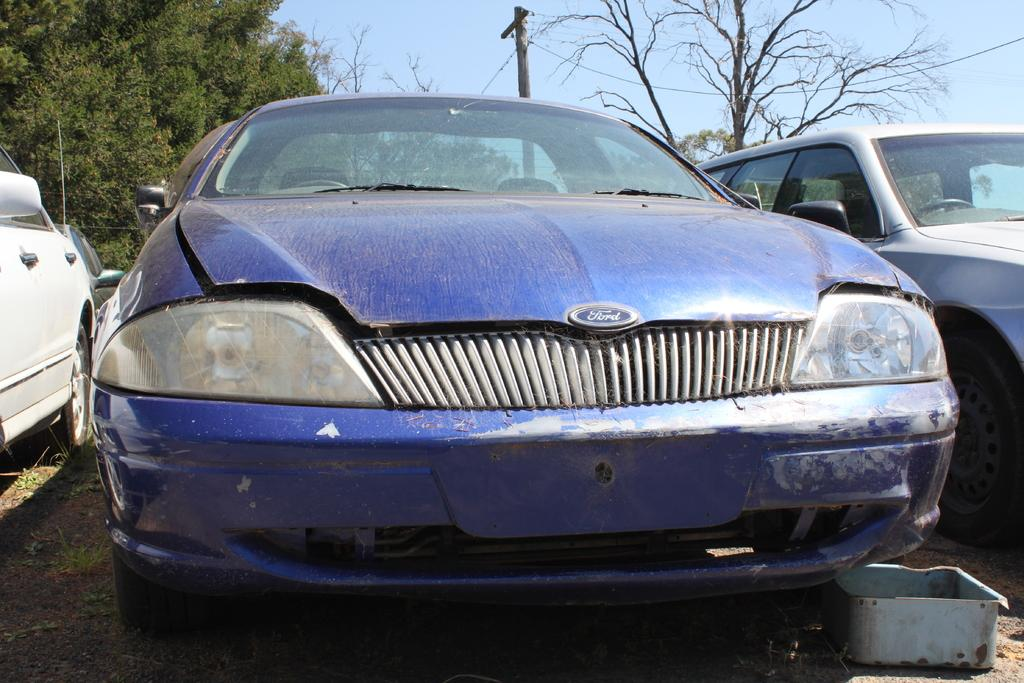What types of vehicles are present in the image? A: There are different colors of cars in the image. What other objects can be seen in the image besides the cars? There is a current pole and trees in the image. What is visible in the background of the image? The sky is visible in the image. Who gave the visitor a haircut in the image? There is no visitor or haircut present in the image. 